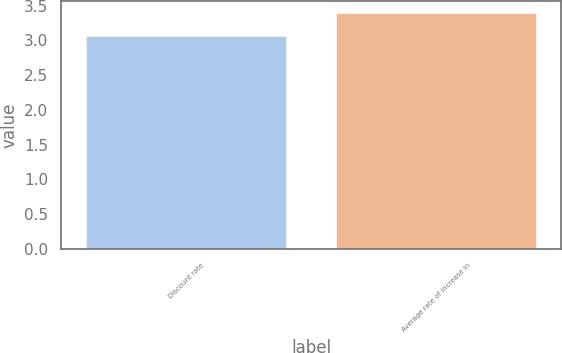Convert chart to OTSL. <chart><loc_0><loc_0><loc_500><loc_500><bar_chart><fcel>Discount rate<fcel>Average rate of increase in<nl><fcel>3.06<fcel>3.4<nl></chart> 